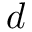<formula> <loc_0><loc_0><loc_500><loc_500>d</formula> 